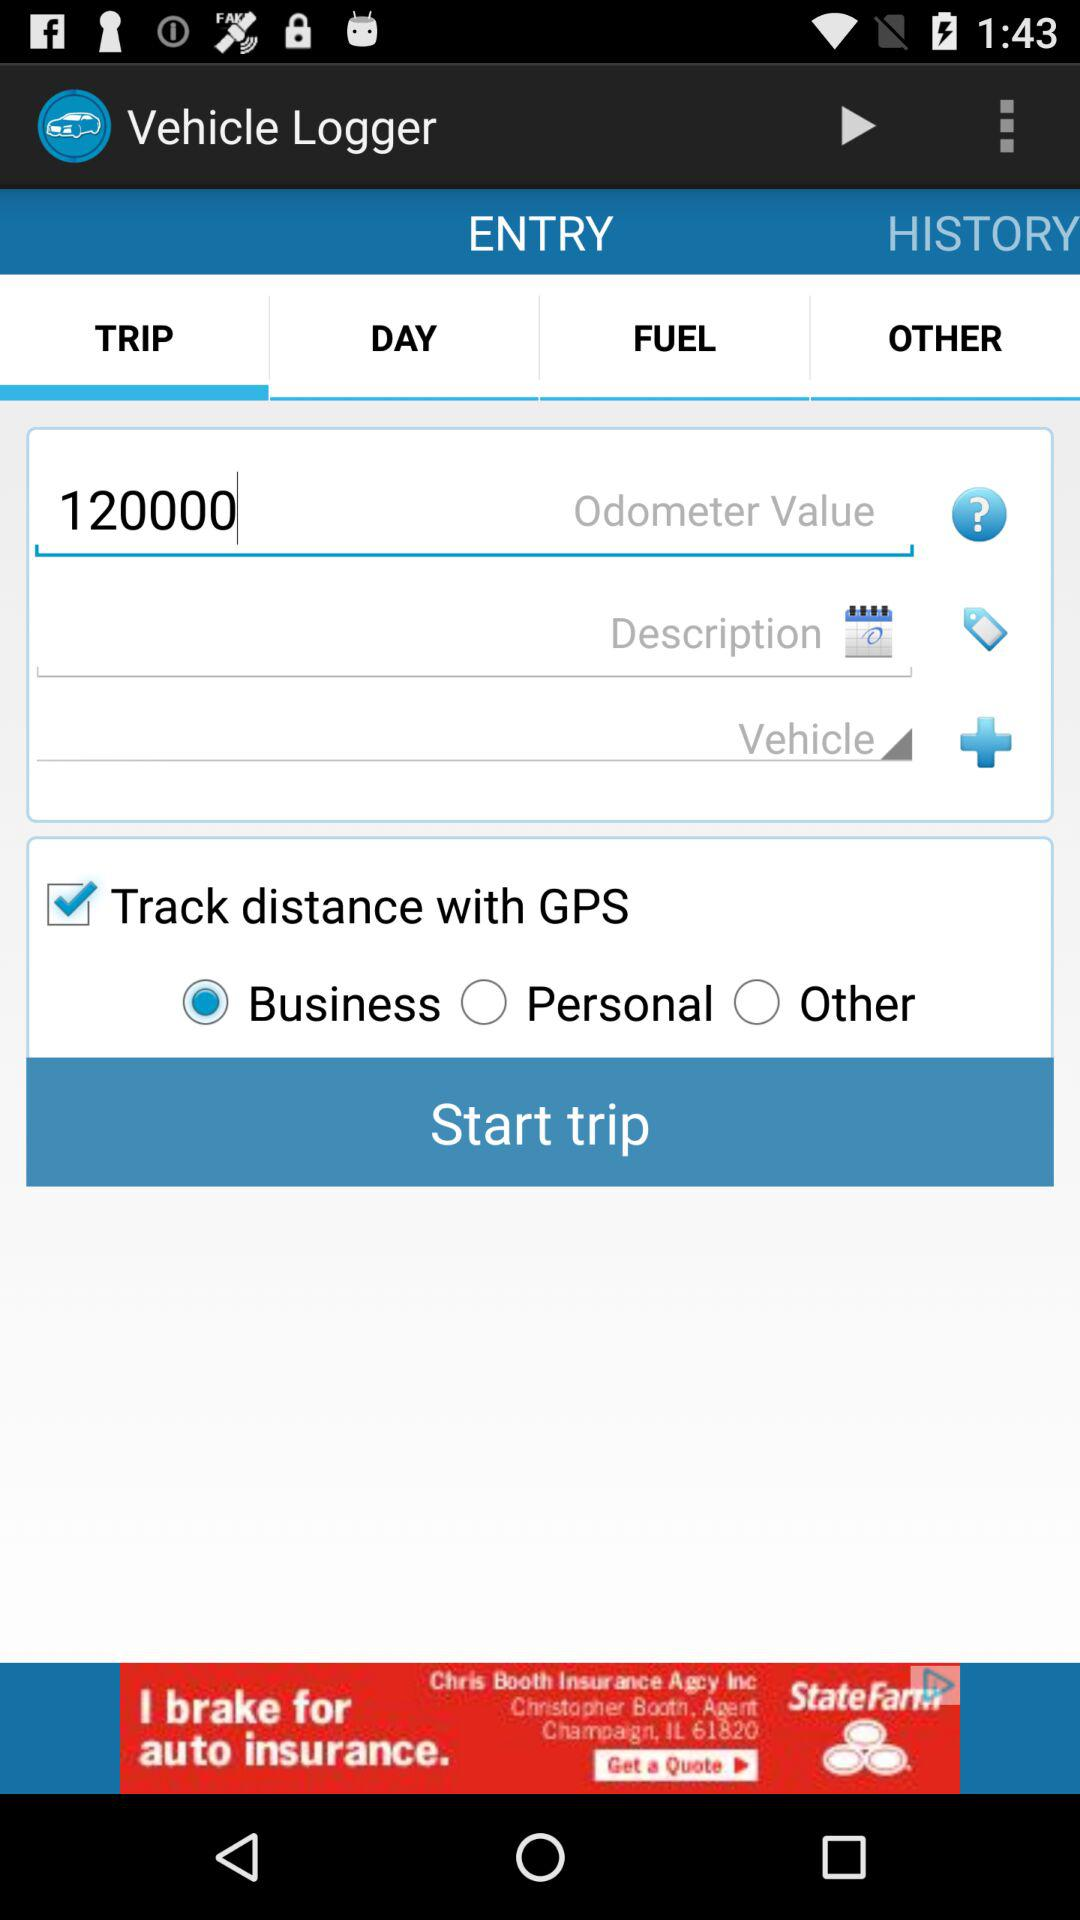Which option is checked? The checked option is "Track distance with GPS". 